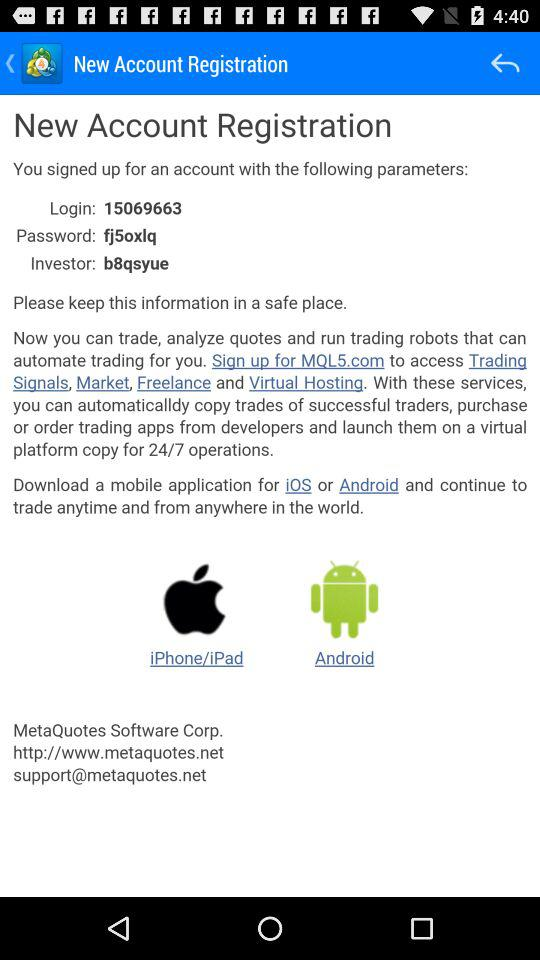What is the investor code? The investor code is "b8qsyue". 